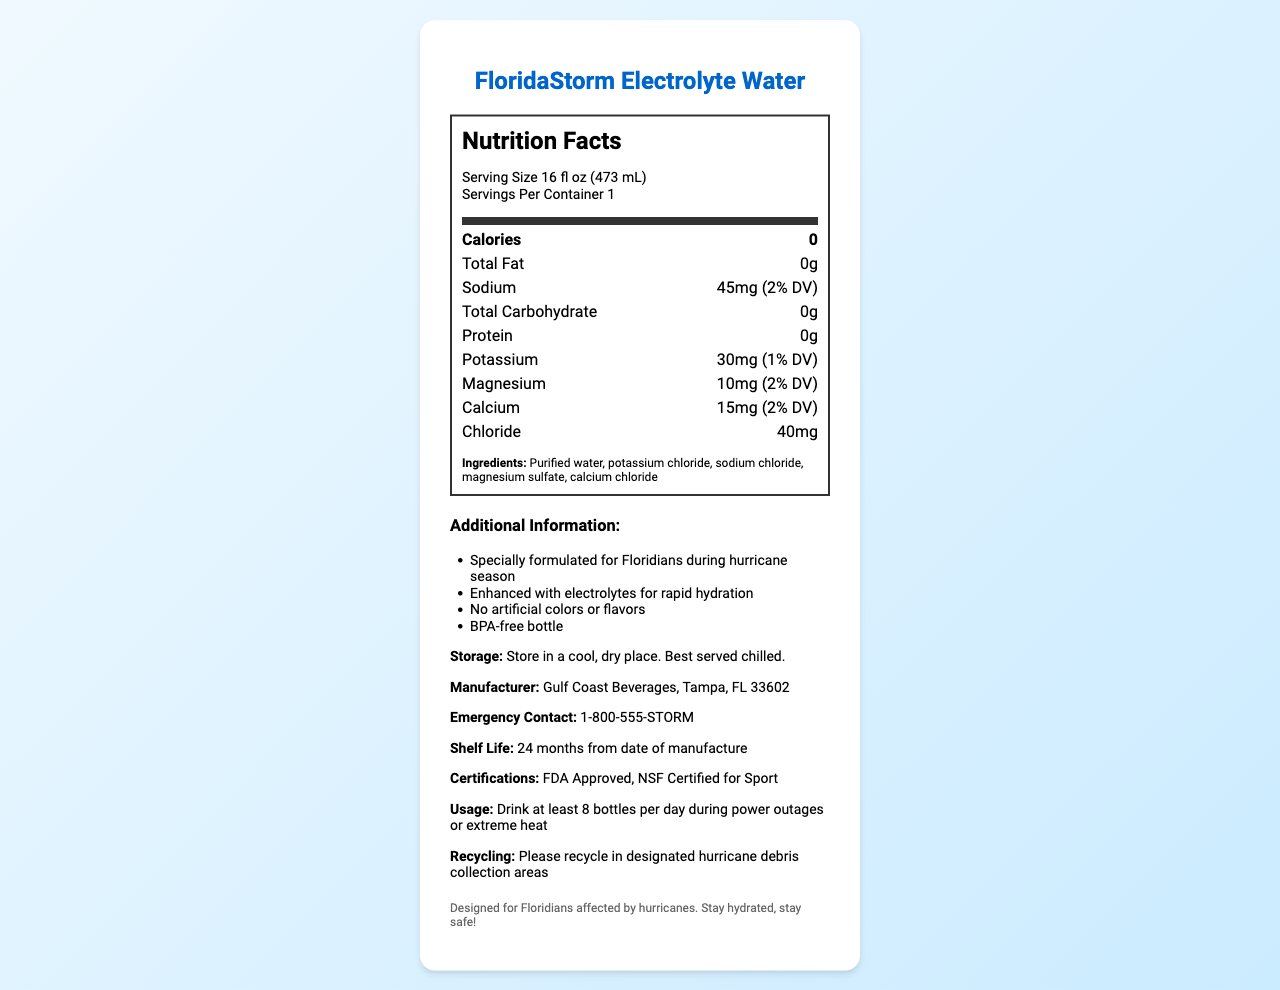what is the serving size of FloridaStorm Electrolyte Water? The serving size is clearly mentioned in the nutrition facts label as "Serving Size 16 fl oz (473 mL)".
Answer: 16 fl oz (473 mL) how many servings are there per container? The serving size is mentioned as “1” per container as indicated in the nutrition facts label.
Answer: 1 how many calories are in one serving of FloridaStorm Electrolyte Water? The nutrition facts section lists the calorie count as 0.
Answer: 0 calories what is the total amount of sodium per serving? The total amount of sodium per serving is listed as 45mg.
Answer: 45mg how much potassium does one serving contain? The nutrition facts section lists the amount of potassium as 30mg per serving.
Answer: 30mg what are the main ingredients of FloridaStorm Electrolyte Water? The ingredients are listed clearly under the "Ingredients" section.
Answer: Purified water, potassium chloride, sodium chloride, magnesium sulfate, calcium chloride which company manufactures FloridaStorm Electrolyte Water? The manufacturer information is mentioned as "Gulf Coast Beverages, Tampa, FL 33602".
Answer: Gulf Coast Beverages, Tampa, FL 33602 how long is the shelf life of this bottled water? The shelf life is specified as "24 months from date of manufacture".
Answer: 24 months from date of manufacture how should this bottled water be stored? It should be stored in a cool, dry place and is best served chilled as specified in the storage instructions.
Answer: Store in a cool, dry place. Best served chilled. what should you do with the bottle after use? The recycling information instructs to recycle in designated hurricane debris collection areas.
Answer: Please recycle in designated hurricane debris collection areas what certifications does FloridaStorm Electrolyte Water have? The certifications listed are "FDA Approved" and "NSF Certified for Sport".
Answer: FDA Approved, NSF Certified for Sport what additional feature makes this product suitable for Floridians during hurricane season? The additional info states that it is "Specially formulated for Floridians during hurricane season".
Answer: Specially formulated for Floridians during hurricane season how much calcium is in one serving of FloridaStorm Electrolyte Water? The label shows that it contains 15mg of calcium per serving, which is 2% of daily value (DV).
Answer: 15mg (2% DV) True or False: The bottle of FloridaStorm Electrolyte Water is BPA-free. The additional info mentions that the bottle is BPA-free.
Answer: True which electrolyte is present in the highest amount in FloridaStorm Electrolyte Water? A. Sodium B. Potassium C. Magnesium D. Calcium The highest electrolyte content is Sodium at 45mg, whereas Potassium, Magnesium, and Calcium are present in lower amounts.
Answer: A. Sodium how many bottles of FloridaStorm Electrolyte Water are recommended during power outages? A. 6 bottles B. 8 bottles C. 10 bottles D. 12 bottles The usage recommendations suggest drinking at least 8 bottles per day.
Answer: B. 8 bottles summarize the main information provided by the document. This summary covers the key points such as the purpose of the product, its nutritional facts, ingredients, and additional usage and storage instructions.
Answer: The document describes "FloridaStorm Electrolyte Water", a specially formulated beverage for Floridians during hurricane season. It includes a 16 fl oz serving size with various electrolytes like sodium, potassium, magnesium, and calcium for hydration. The water is calorie-free and contains no artificial colors or flavors. Additional information includes storage instructions, manufacturer details, shelf life, certifications, usage recommendations, and recycling information. what is the daily value (DV) percentage of chloride in a serving? The document does not provide the daily value (DV) percentage for chloride, only the quantity in milligrams.
Answer: Not enough information 